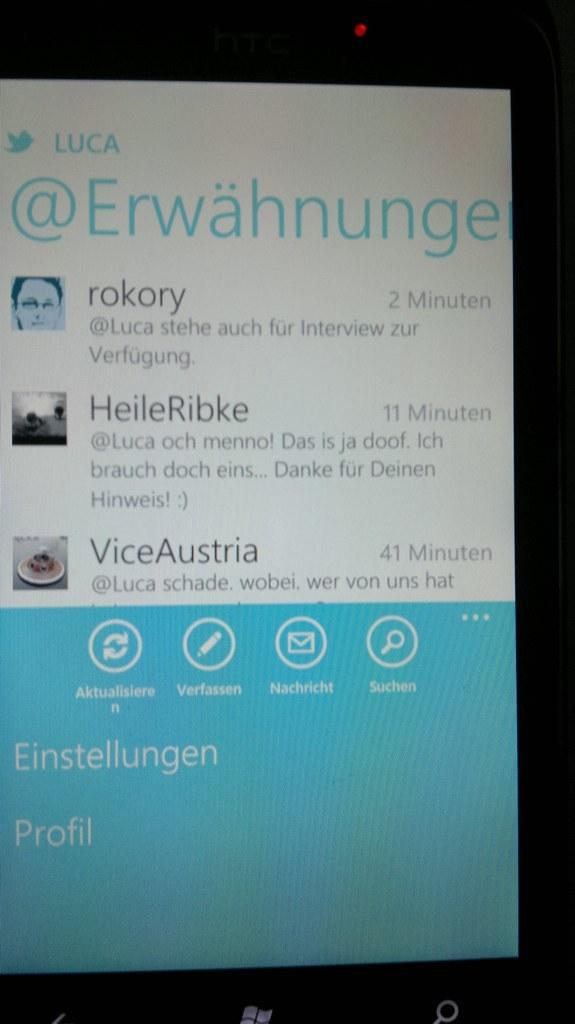<image>
Relay a brief, clear account of the picture shown. A tablet screen showing posts from rokory, HeileRibke, and ViceAustria. 